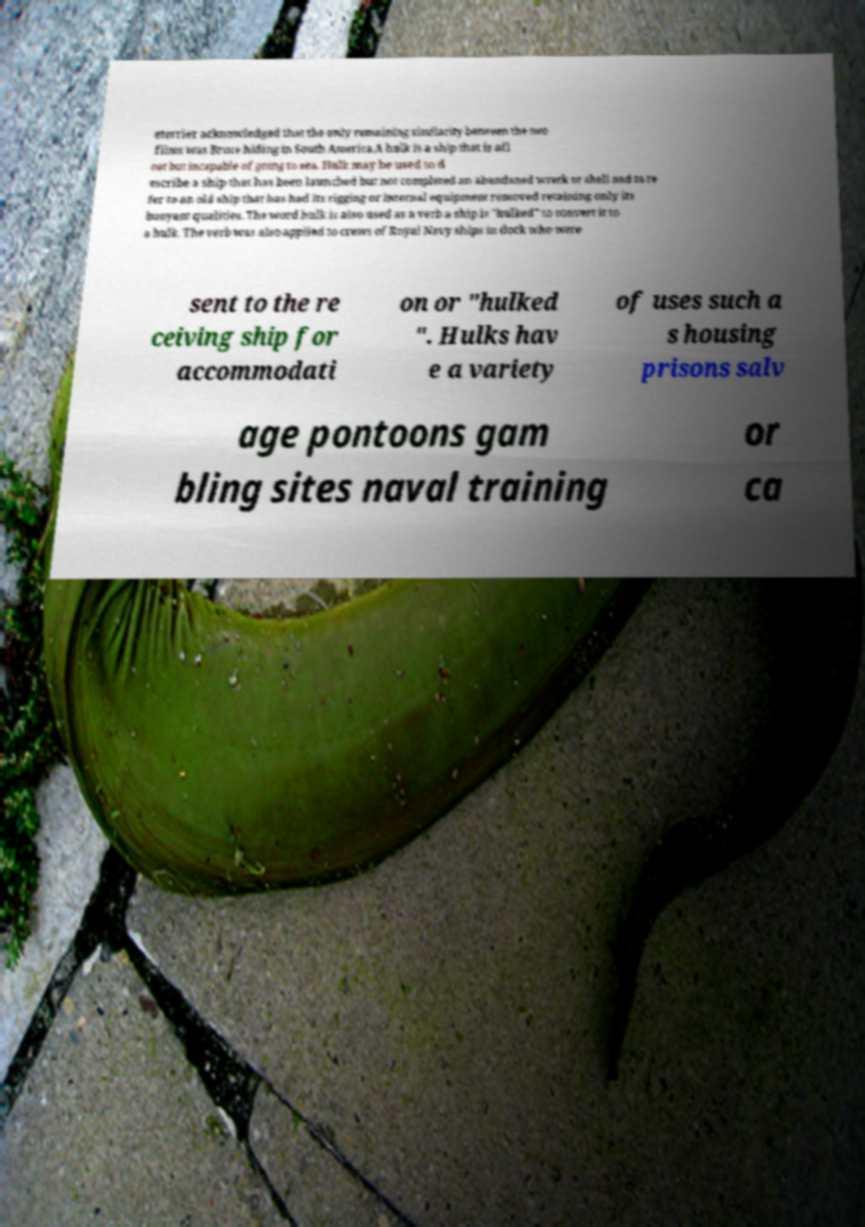What messages or text are displayed in this image? I need them in a readable, typed format. eterrier acknowledged that the only remaining similarity between the two films was Bruce hiding in South America.A hulk is a ship that is afl oat but incapable of going to sea. Hulk may be used to d escribe a ship that has been launched but not completed an abandoned wreck or shell and to re fer to an old ship that has had its rigging or internal equipment removed retaining only its buoyant qualities. The word hulk is also used as a verb a ship is "hulked" to convert it to a hulk. The verb was also applied to crews of Royal Navy ships in dock who were sent to the re ceiving ship for accommodati on or "hulked ". Hulks hav e a variety of uses such a s housing prisons salv age pontoons gam bling sites naval training or ca 